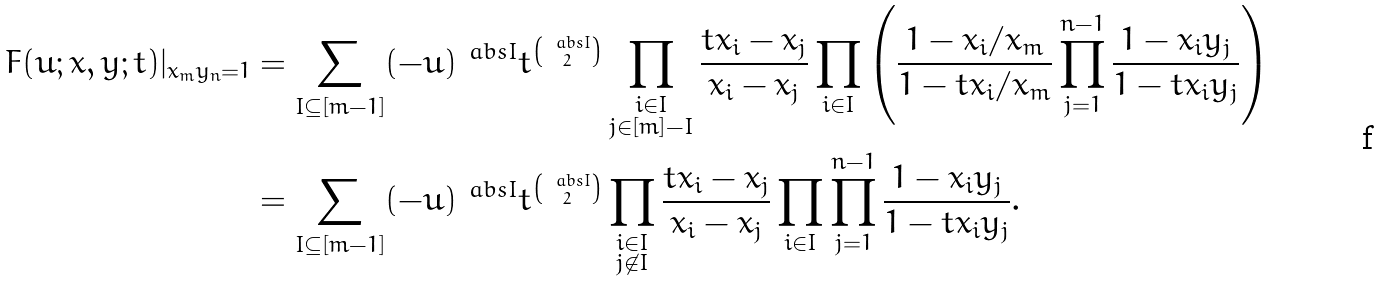Convert formula to latex. <formula><loc_0><loc_0><loc_500><loc_500>F ( u ; x , y ; t ) | _ { x _ { m } y _ { n } = 1 } & = \sum _ { I \subseteq [ m - 1 ] } ( - u ) ^ { \ a b s { I } } t ^ { \binom { \ a b s { I } } { 2 } } \prod _ { \substack { i \in I \\ j \in [ m ] - I } } \frac { t x _ { i } - x _ { j } } { x _ { i } - x _ { j } } \prod _ { i \in I } \left ( \frac { 1 - x _ { i } / x _ { m } } { 1 - t x _ { i } / x _ { m } } \prod _ { j = 1 } ^ { n - 1 } \frac { 1 - x _ { i } y _ { j } } { 1 - t x _ { i } y _ { j } } \right ) \\ & = \sum _ { I \subseteq [ m - 1 ] } ( - u ) ^ { \ a b s { I } } t ^ { \binom { \ a b s { I } } { 2 } } \prod _ { \substack { i \in I \\ j \not \in I } } \frac { t x _ { i } - x _ { j } } { x _ { i } - x _ { j } } \prod _ { i \in I } \prod _ { j = 1 } ^ { n - 1 } \frac { 1 - x _ { i } y _ { j } } { 1 - t x _ { i } y _ { j } } .</formula> 